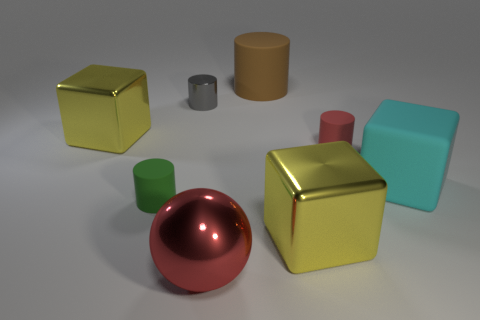Subtract all green spheres. Subtract all brown blocks. How many spheres are left? 1 Add 1 brown things. How many objects exist? 9 Subtract all balls. How many objects are left? 7 Add 2 small rubber cylinders. How many small rubber cylinders exist? 4 Subtract 0 gray cubes. How many objects are left? 8 Subtract all big gray objects. Subtract all yellow things. How many objects are left? 6 Add 3 green cylinders. How many green cylinders are left? 4 